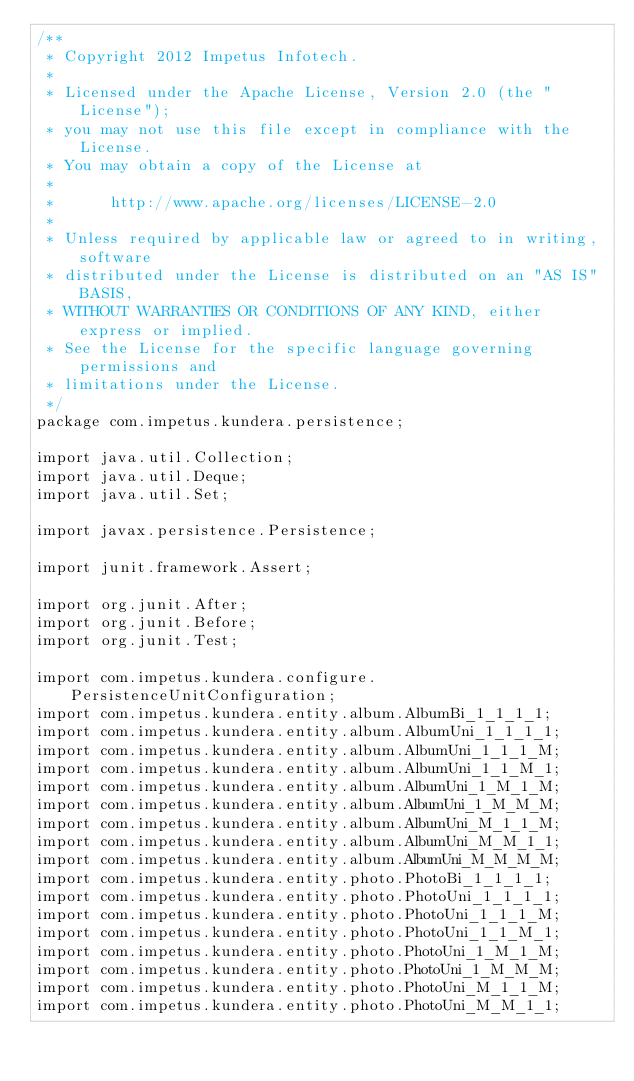Convert code to text. <code><loc_0><loc_0><loc_500><loc_500><_Java_>/**
 * Copyright 2012 Impetus Infotech.
 *
 * Licensed under the Apache License, Version 2.0 (the "License");
 * you may not use this file except in compliance with the License.
 * You may obtain a copy of the License at
 *
 *      http://www.apache.org/licenses/LICENSE-2.0
 *
 * Unless required by applicable law or agreed to in writing, software
 * distributed under the License is distributed on an "AS IS" BASIS,
 * WITHOUT WARRANTIES OR CONDITIONS OF ANY KIND, either express or implied.
 * See the License for the specific language governing permissions and
 * limitations under the License.
 */
package com.impetus.kundera.persistence;

import java.util.Collection;
import java.util.Deque;
import java.util.Set;

import javax.persistence.Persistence;

import junit.framework.Assert;

import org.junit.After;
import org.junit.Before;
import org.junit.Test;

import com.impetus.kundera.configure.PersistenceUnitConfiguration;
import com.impetus.kundera.entity.album.AlbumBi_1_1_1_1;
import com.impetus.kundera.entity.album.AlbumUni_1_1_1_1;
import com.impetus.kundera.entity.album.AlbumUni_1_1_1_M;
import com.impetus.kundera.entity.album.AlbumUni_1_1_M_1;
import com.impetus.kundera.entity.album.AlbumUni_1_M_1_M;
import com.impetus.kundera.entity.album.AlbumUni_1_M_M_M;
import com.impetus.kundera.entity.album.AlbumUni_M_1_1_M;
import com.impetus.kundera.entity.album.AlbumUni_M_M_1_1;
import com.impetus.kundera.entity.album.AlbumUni_M_M_M_M;
import com.impetus.kundera.entity.photo.PhotoBi_1_1_1_1;
import com.impetus.kundera.entity.photo.PhotoUni_1_1_1_1;
import com.impetus.kundera.entity.photo.PhotoUni_1_1_1_M;
import com.impetus.kundera.entity.photo.PhotoUni_1_1_M_1;
import com.impetus.kundera.entity.photo.PhotoUni_1_M_1_M;
import com.impetus.kundera.entity.photo.PhotoUni_1_M_M_M;
import com.impetus.kundera.entity.photo.PhotoUni_M_1_1_M;
import com.impetus.kundera.entity.photo.PhotoUni_M_M_1_1;</code> 